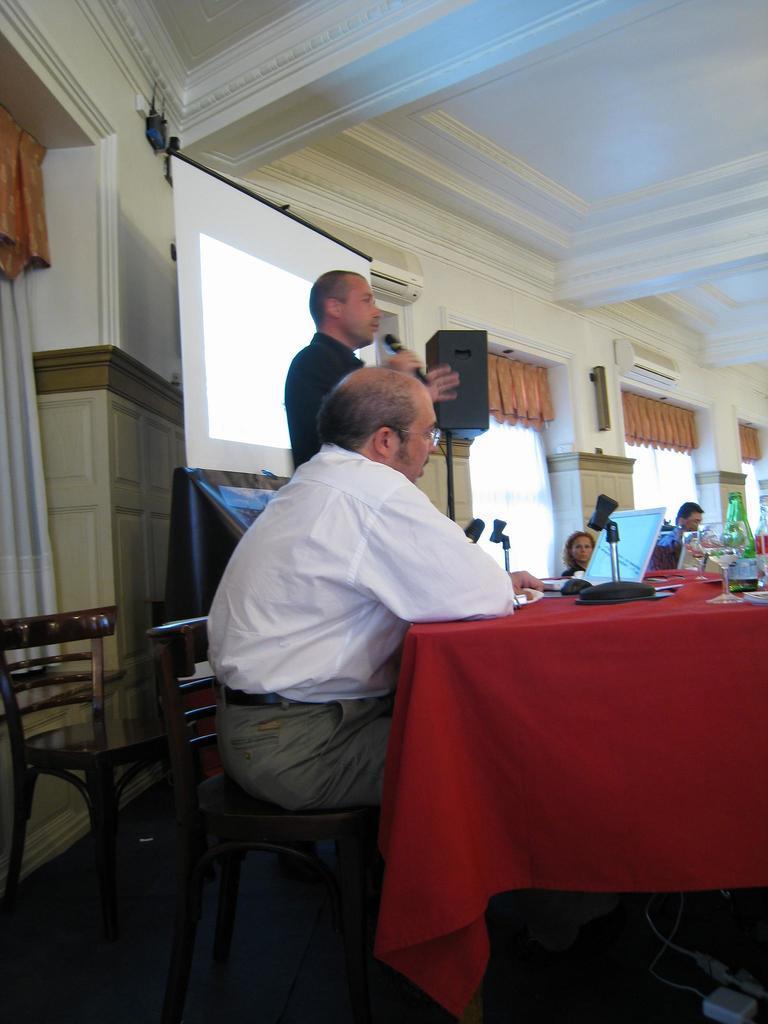Can you describe this image briefly? In the middle of this image I can see a man wearing white shirt and sitting on the chair. Beside this person there is another person wearing black jacket, standing and speaking by holding a mike in his hands. At the back of this person I can see a screen. In the background I can see a wall. On the left side of this image I can see a white curtain. On the right side of this image there is a table covered with a red color cloth, there are some bottles, laptop, glasses are placed on it. On the right bottom of this image there is a box. 